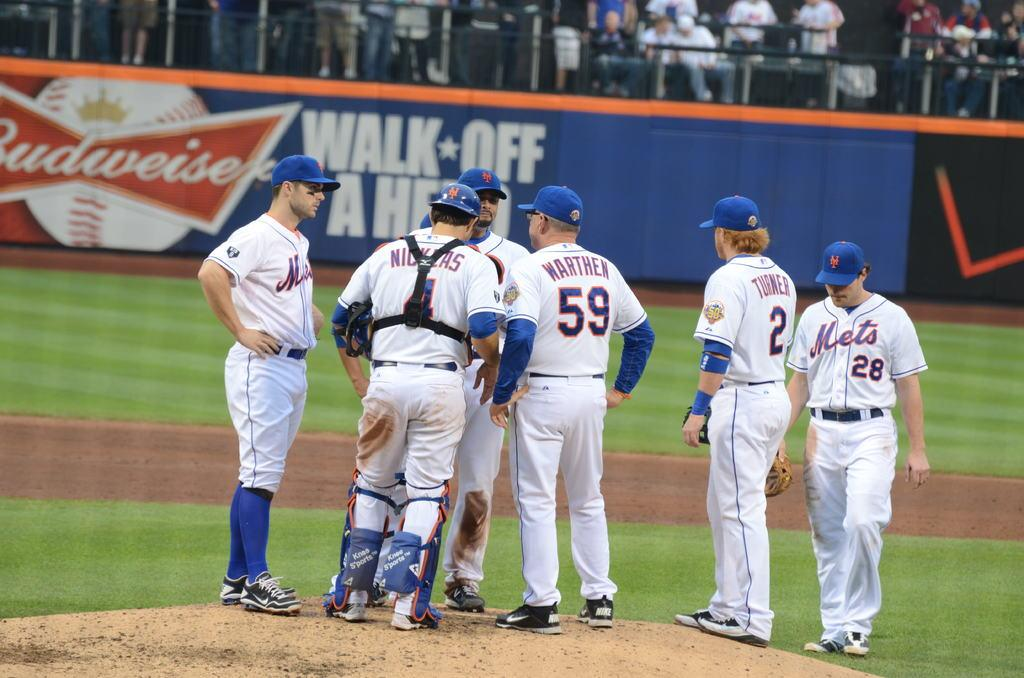<image>
Write a terse but informative summary of the picture. some players with numbers on their jerseys including 59 